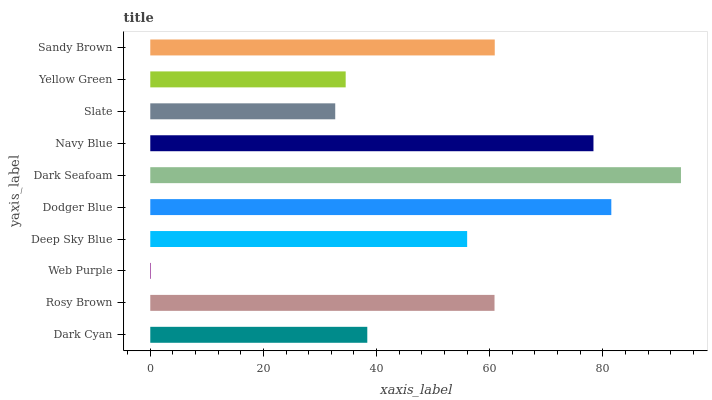Is Web Purple the minimum?
Answer yes or no. Yes. Is Dark Seafoam the maximum?
Answer yes or no. Yes. Is Rosy Brown the minimum?
Answer yes or no. No. Is Rosy Brown the maximum?
Answer yes or no. No. Is Rosy Brown greater than Dark Cyan?
Answer yes or no. Yes. Is Dark Cyan less than Rosy Brown?
Answer yes or no. Yes. Is Dark Cyan greater than Rosy Brown?
Answer yes or no. No. Is Rosy Brown less than Dark Cyan?
Answer yes or no. No. Is Rosy Brown the high median?
Answer yes or no. Yes. Is Deep Sky Blue the low median?
Answer yes or no. Yes. Is Dark Seafoam the high median?
Answer yes or no. No. Is Yellow Green the low median?
Answer yes or no. No. 